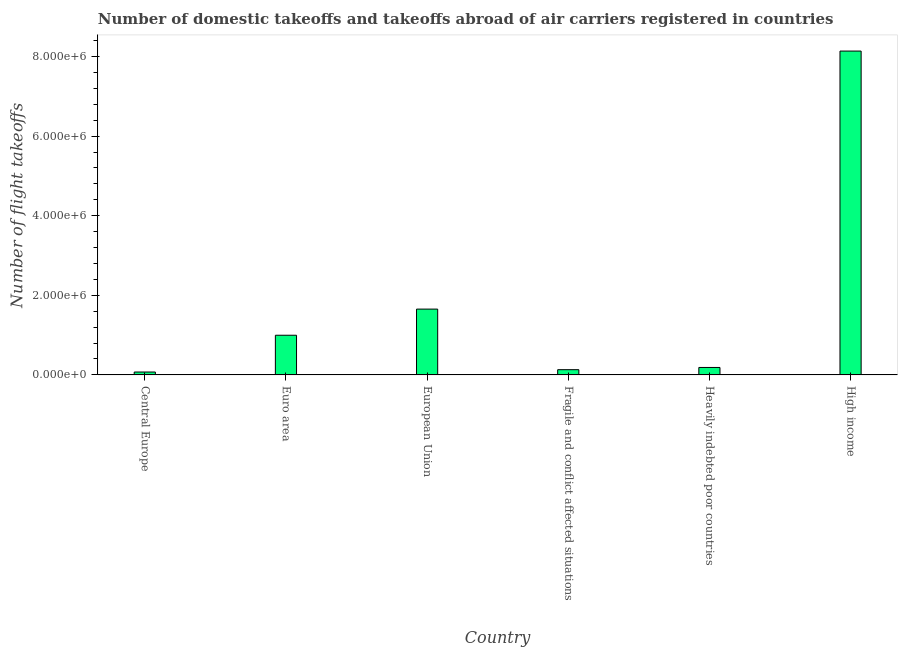What is the title of the graph?
Offer a terse response. Number of domestic takeoffs and takeoffs abroad of air carriers registered in countries. What is the label or title of the X-axis?
Your answer should be very brief. Country. What is the label or title of the Y-axis?
Your answer should be very brief. Number of flight takeoffs. What is the number of flight takeoffs in Central Europe?
Give a very brief answer. 7.27e+04. Across all countries, what is the maximum number of flight takeoffs?
Make the answer very short. 8.14e+06. Across all countries, what is the minimum number of flight takeoffs?
Offer a very short reply. 7.27e+04. In which country was the number of flight takeoffs minimum?
Give a very brief answer. Central Europe. What is the sum of the number of flight takeoffs?
Offer a very short reply. 1.12e+07. What is the difference between the number of flight takeoffs in European Union and Heavily indebted poor countries?
Give a very brief answer. 1.47e+06. What is the average number of flight takeoffs per country?
Offer a very short reply. 1.86e+06. What is the median number of flight takeoffs?
Keep it short and to the point. 5.92e+05. What is the ratio of the number of flight takeoffs in Central Europe to that in Heavily indebted poor countries?
Provide a short and direct response. 0.39. Is the number of flight takeoffs in Central Europe less than that in Euro area?
Ensure brevity in your answer.  Yes. What is the difference between the highest and the second highest number of flight takeoffs?
Your answer should be compact. 6.48e+06. Is the sum of the number of flight takeoffs in Heavily indebted poor countries and High income greater than the maximum number of flight takeoffs across all countries?
Offer a terse response. Yes. What is the difference between the highest and the lowest number of flight takeoffs?
Give a very brief answer. 8.06e+06. In how many countries, is the number of flight takeoffs greater than the average number of flight takeoffs taken over all countries?
Provide a short and direct response. 1. How many bars are there?
Provide a short and direct response. 6. What is the Number of flight takeoffs in Central Europe?
Provide a short and direct response. 7.27e+04. What is the Number of flight takeoffs in Euro area?
Offer a very short reply. 9.96e+05. What is the Number of flight takeoffs in European Union?
Provide a succinct answer. 1.65e+06. What is the Number of flight takeoffs of Fragile and conflict affected situations?
Keep it short and to the point. 1.32e+05. What is the Number of flight takeoffs in Heavily indebted poor countries?
Your response must be concise. 1.87e+05. What is the Number of flight takeoffs of High income?
Keep it short and to the point. 8.14e+06. What is the difference between the Number of flight takeoffs in Central Europe and Euro area?
Provide a succinct answer. -9.24e+05. What is the difference between the Number of flight takeoffs in Central Europe and European Union?
Keep it short and to the point. -1.58e+06. What is the difference between the Number of flight takeoffs in Central Europe and Fragile and conflict affected situations?
Keep it short and to the point. -5.88e+04. What is the difference between the Number of flight takeoffs in Central Europe and Heavily indebted poor countries?
Keep it short and to the point. -1.14e+05. What is the difference between the Number of flight takeoffs in Central Europe and High income?
Offer a very short reply. -8.06e+06. What is the difference between the Number of flight takeoffs in Euro area and European Union?
Keep it short and to the point. -6.57e+05. What is the difference between the Number of flight takeoffs in Euro area and Fragile and conflict affected situations?
Offer a very short reply. 8.65e+05. What is the difference between the Number of flight takeoffs in Euro area and Heavily indebted poor countries?
Make the answer very short. 8.09e+05. What is the difference between the Number of flight takeoffs in Euro area and High income?
Offer a very short reply. -7.14e+06. What is the difference between the Number of flight takeoffs in European Union and Fragile and conflict affected situations?
Your answer should be compact. 1.52e+06. What is the difference between the Number of flight takeoffs in European Union and Heavily indebted poor countries?
Ensure brevity in your answer.  1.47e+06. What is the difference between the Number of flight takeoffs in European Union and High income?
Make the answer very short. -6.48e+06. What is the difference between the Number of flight takeoffs in Fragile and conflict affected situations and Heavily indebted poor countries?
Keep it short and to the point. -5.56e+04. What is the difference between the Number of flight takeoffs in Fragile and conflict affected situations and High income?
Provide a succinct answer. -8.00e+06. What is the difference between the Number of flight takeoffs in Heavily indebted poor countries and High income?
Your answer should be compact. -7.95e+06. What is the ratio of the Number of flight takeoffs in Central Europe to that in Euro area?
Ensure brevity in your answer.  0.07. What is the ratio of the Number of flight takeoffs in Central Europe to that in European Union?
Keep it short and to the point. 0.04. What is the ratio of the Number of flight takeoffs in Central Europe to that in Fragile and conflict affected situations?
Make the answer very short. 0.55. What is the ratio of the Number of flight takeoffs in Central Europe to that in Heavily indebted poor countries?
Provide a short and direct response. 0.39. What is the ratio of the Number of flight takeoffs in Central Europe to that in High income?
Make the answer very short. 0.01. What is the ratio of the Number of flight takeoffs in Euro area to that in European Union?
Provide a short and direct response. 0.6. What is the ratio of the Number of flight takeoffs in Euro area to that in Fragile and conflict affected situations?
Offer a terse response. 7.58. What is the ratio of the Number of flight takeoffs in Euro area to that in Heavily indebted poor countries?
Keep it short and to the point. 5.33. What is the ratio of the Number of flight takeoffs in Euro area to that in High income?
Your answer should be compact. 0.12. What is the ratio of the Number of flight takeoffs in European Union to that in Fragile and conflict affected situations?
Offer a very short reply. 12.57. What is the ratio of the Number of flight takeoffs in European Union to that in Heavily indebted poor countries?
Offer a very short reply. 8.84. What is the ratio of the Number of flight takeoffs in European Union to that in High income?
Ensure brevity in your answer.  0.2. What is the ratio of the Number of flight takeoffs in Fragile and conflict affected situations to that in Heavily indebted poor countries?
Give a very brief answer. 0.7. What is the ratio of the Number of flight takeoffs in Fragile and conflict affected situations to that in High income?
Your answer should be very brief. 0.02. What is the ratio of the Number of flight takeoffs in Heavily indebted poor countries to that in High income?
Your answer should be very brief. 0.02. 